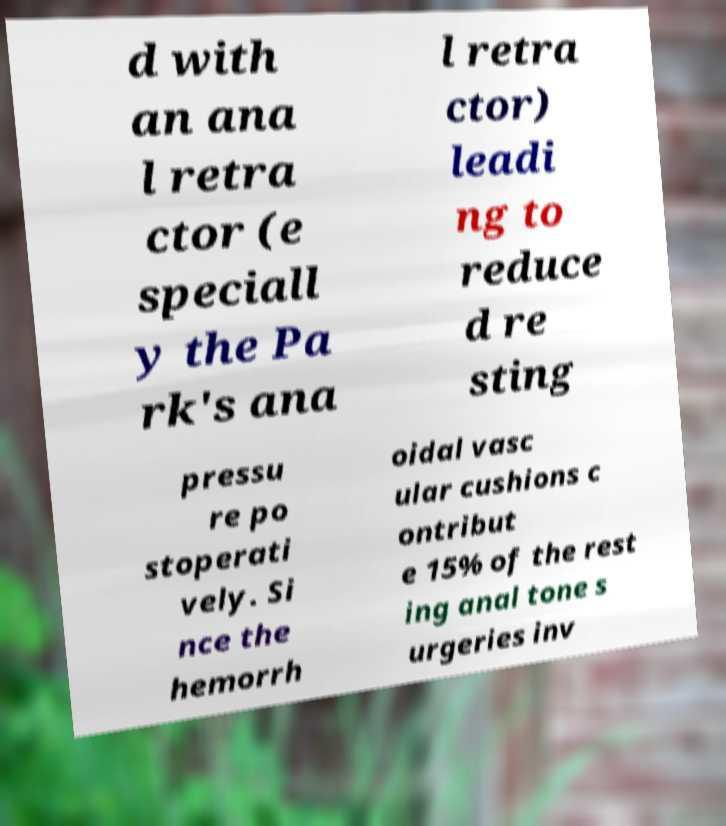I need the written content from this picture converted into text. Can you do that? d with an ana l retra ctor (e speciall y the Pa rk's ana l retra ctor) leadi ng to reduce d re sting pressu re po stoperati vely. Si nce the hemorrh oidal vasc ular cushions c ontribut e 15% of the rest ing anal tone s urgeries inv 